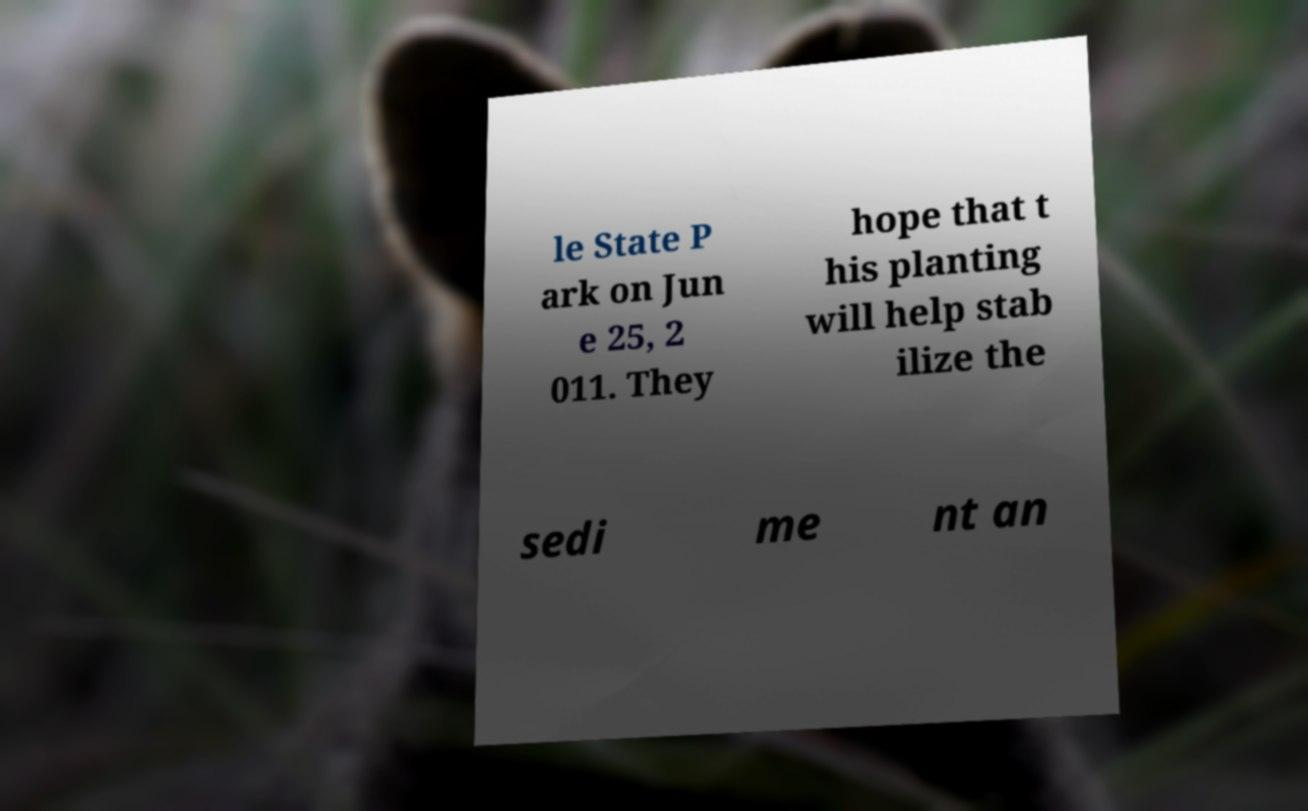Please read and relay the text visible in this image. What does it say? le State P ark on Jun e 25, 2 011. They hope that t his planting will help stab ilize the sedi me nt an 